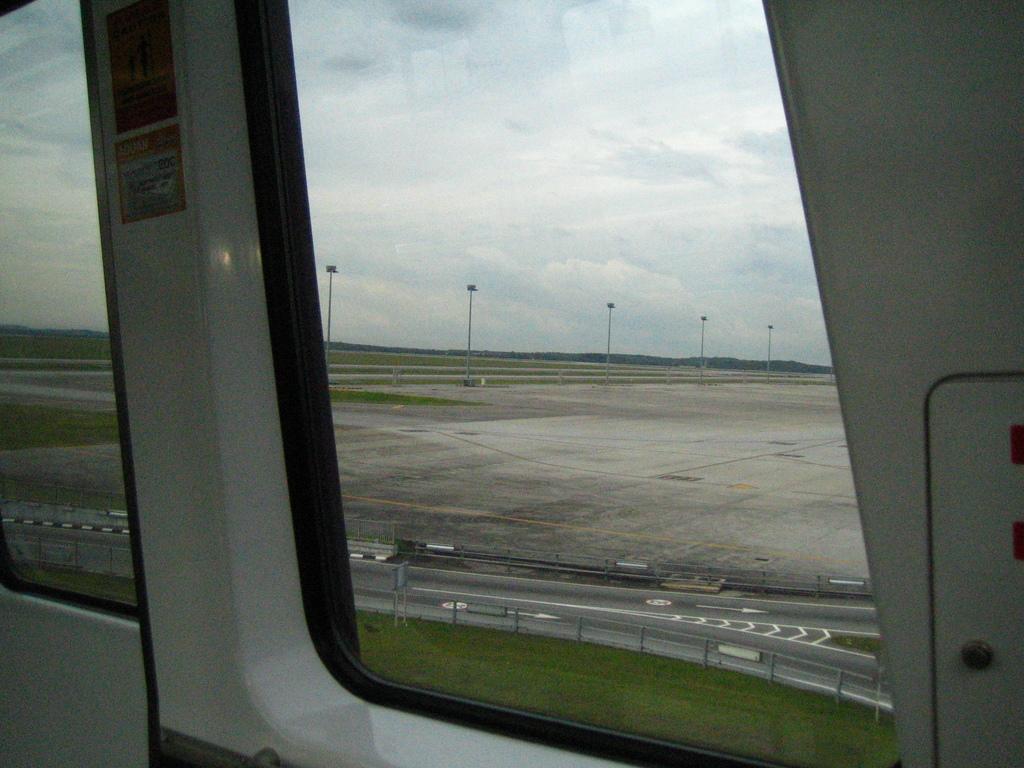Please provide a concise description of this image. Here, we can see some glass windows, in the background there is a road and there are some poles, at the top there is a sky which is cloudy. 